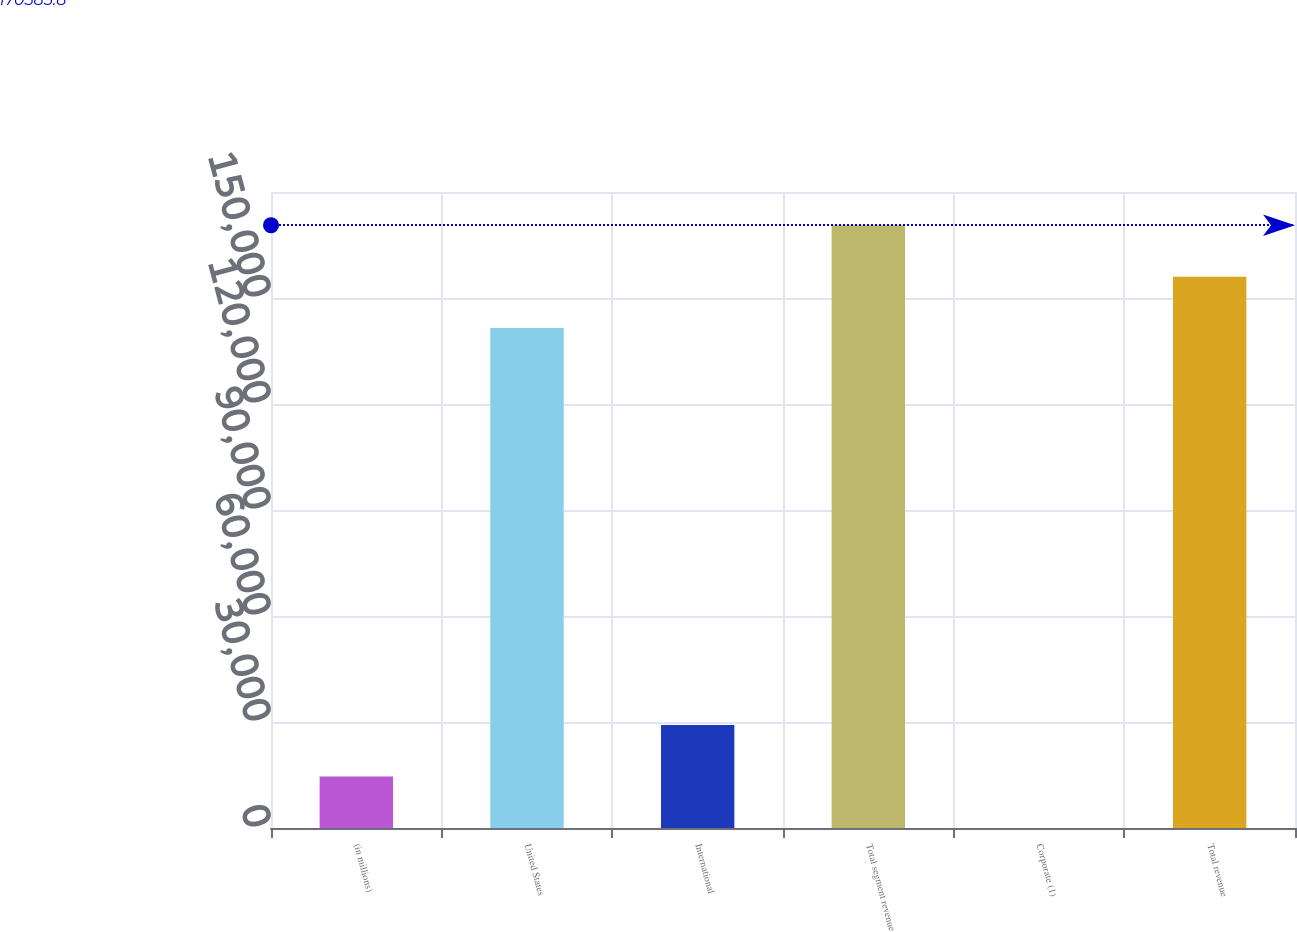Convert chart to OTSL. <chart><loc_0><loc_0><loc_500><loc_500><bar_chart><fcel>(in millions)<fcel>United States<fcel>International<fcel>Total segment revenue<fcel>Corporate (1)<fcel>Total revenue<nl><fcel>14569.4<fcel>141479<fcel>29122.8<fcel>170586<fcel>16<fcel>156032<nl></chart> 